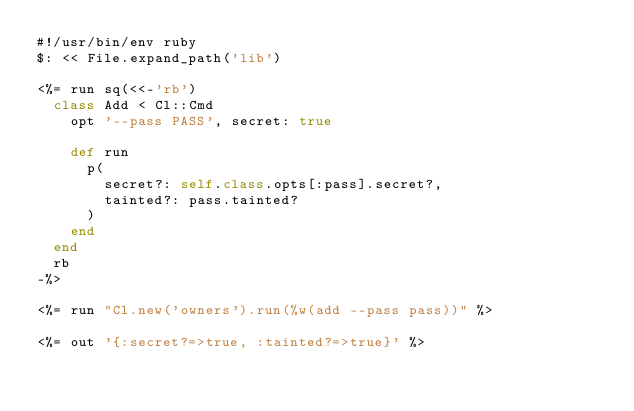<code> <loc_0><loc_0><loc_500><loc_500><_Ruby_>#!/usr/bin/env ruby
$: << File.expand_path('lib')

<%= run sq(<<-'rb')
  class Add < Cl::Cmd
    opt '--pass PASS', secret: true

    def run
      p(
        secret?: self.class.opts[:pass].secret?,
        tainted?: pass.tainted?
      )
    end
  end
  rb
-%>

<%= run "Cl.new('owners').run(%w(add --pass pass))" %>

<%= out '{:secret?=>true, :tainted?=>true}' %>
</code> 